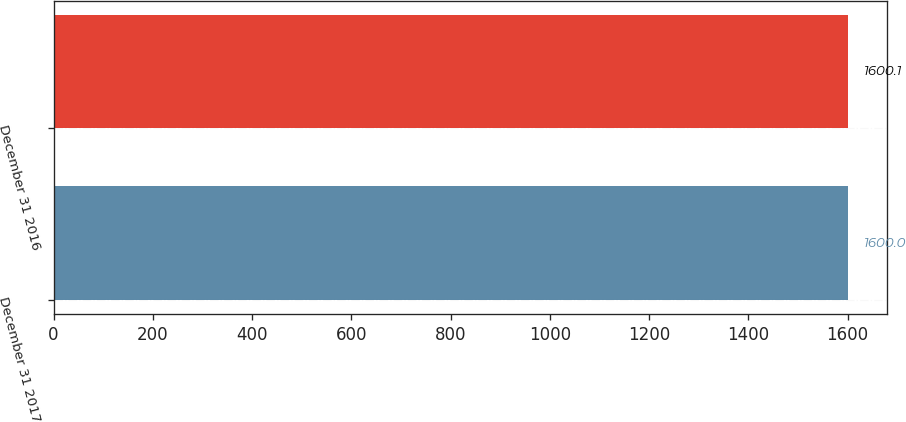Convert chart. <chart><loc_0><loc_0><loc_500><loc_500><bar_chart><fcel>December 31 2017<fcel>December 31 2016<nl><fcel>1600<fcel>1600.1<nl></chart> 